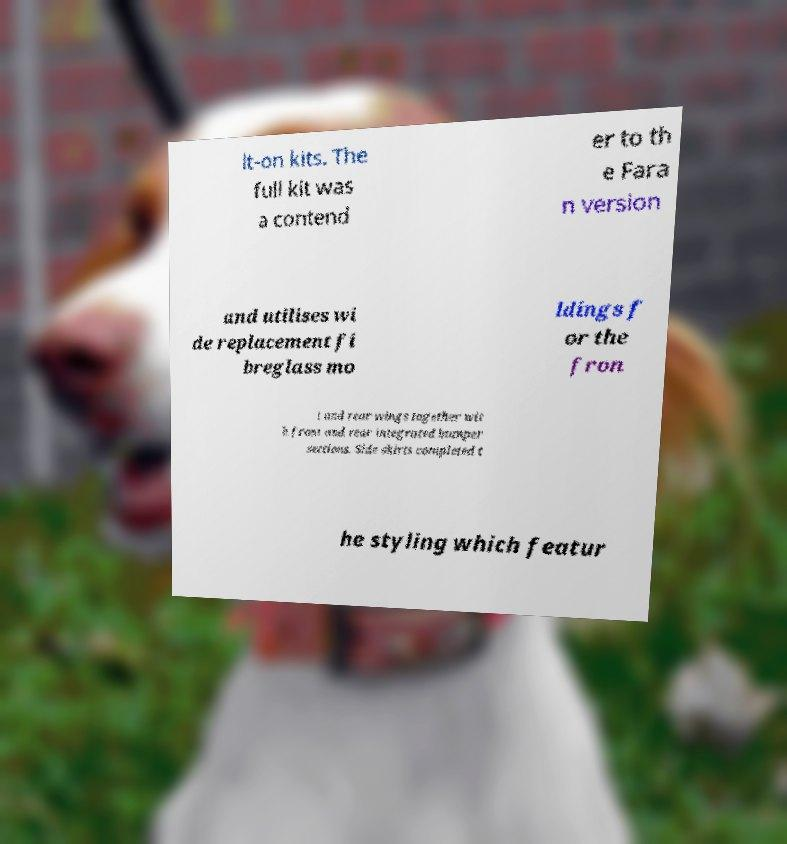Can you read and provide the text displayed in the image?This photo seems to have some interesting text. Can you extract and type it out for me? lt-on kits. The full kit was a contend er to th e Fara n version and utilises wi de replacement fi breglass mo ldings f or the fron t and rear wings together wit h front and rear integrated bumper sections. Side skirts completed t he styling which featur 